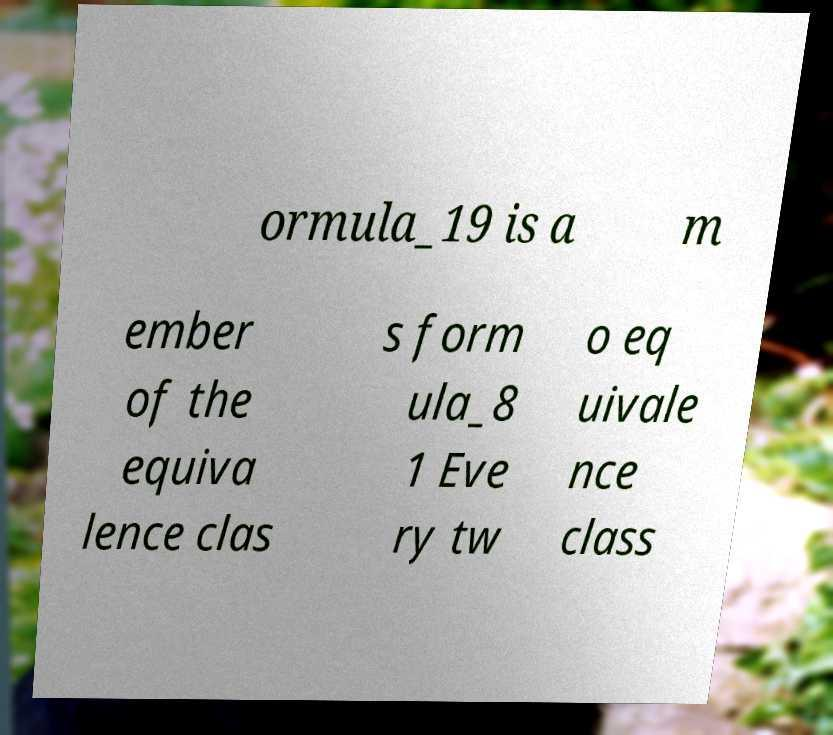Can you accurately transcribe the text from the provided image for me? ormula_19 is a m ember of the equiva lence clas s form ula_8 1 Eve ry tw o eq uivale nce class 